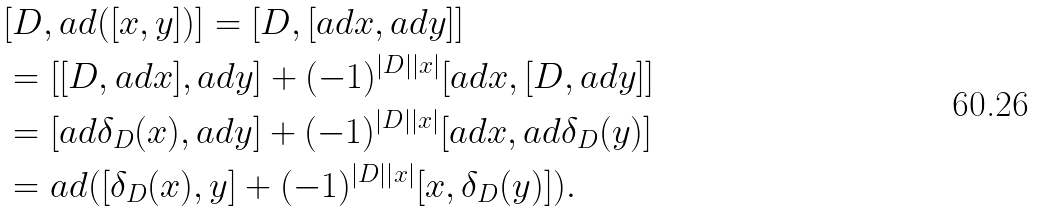Convert formula to latex. <formula><loc_0><loc_0><loc_500><loc_500>& [ D , a d ( [ x , y ] ) ] = [ D , [ a d x , a d y ] ] \\ & = [ [ D , a d x ] , a d y ] + ( - 1 ) ^ { \left | D \right | \left | x \right | } [ a d x , [ D , a d y ] ] \\ & = [ a d \delta _ { D } ( x ) , a d y ] + ( - 1 ) ^ { \left | D \right | \left | x \right | } [ a d x , a d \delta _ { D } ( y ) ] \\ & = a d ( [ \delta _ { D } ( x ) , y ] + ( - 1 ) ^ { \left | D \right | \left | x \right | } [ x , \delta _ { D } ( y ) ] ) . \\</formula> 